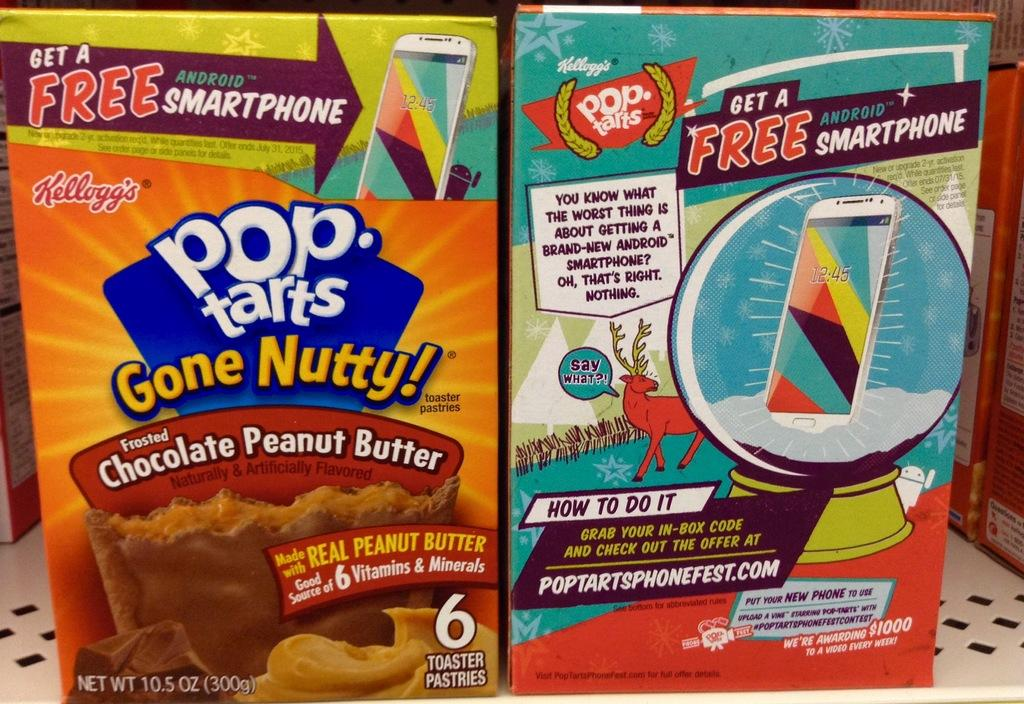What objects are present in the image? There are boxes in the image. What is written or printed on the boxes? There is text on the boxes. What type of images can be seen on the boxes? There are cartoon images on the boxes. Can you see any islands in the image? There are no islands present in the image; it features boxes with text and cartoon images. Is there any steam coming from the boxes in the image? There is no steam present in the image; it features boxes with text and cartoon images. 